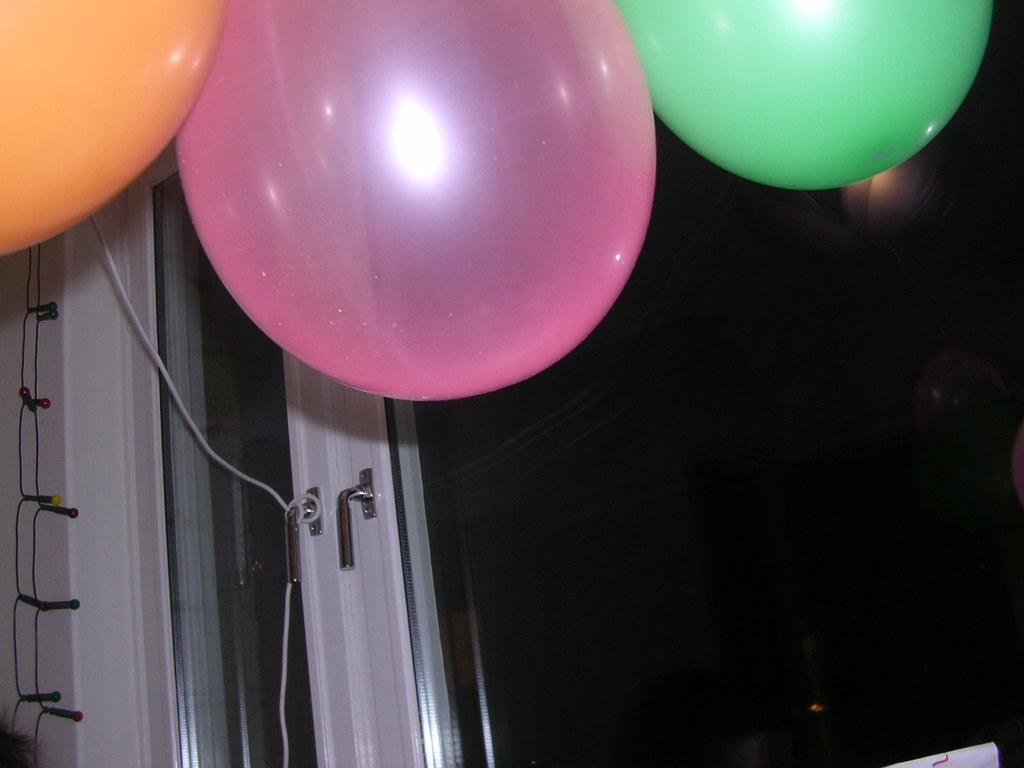What type of door is visible in the image? There is a glass door in the image. What decorative items can be seen at the top of the image? Balloons are present at the top of the image. What type of lighting is featured in the image? Colorful lights are hanging in the image. What type of water can be seen flowing through the metal pipes in the image? There is no water or metal pipes present in the image. What type of songs are being sung by the people in the image? There are no people or songs present in the image. 